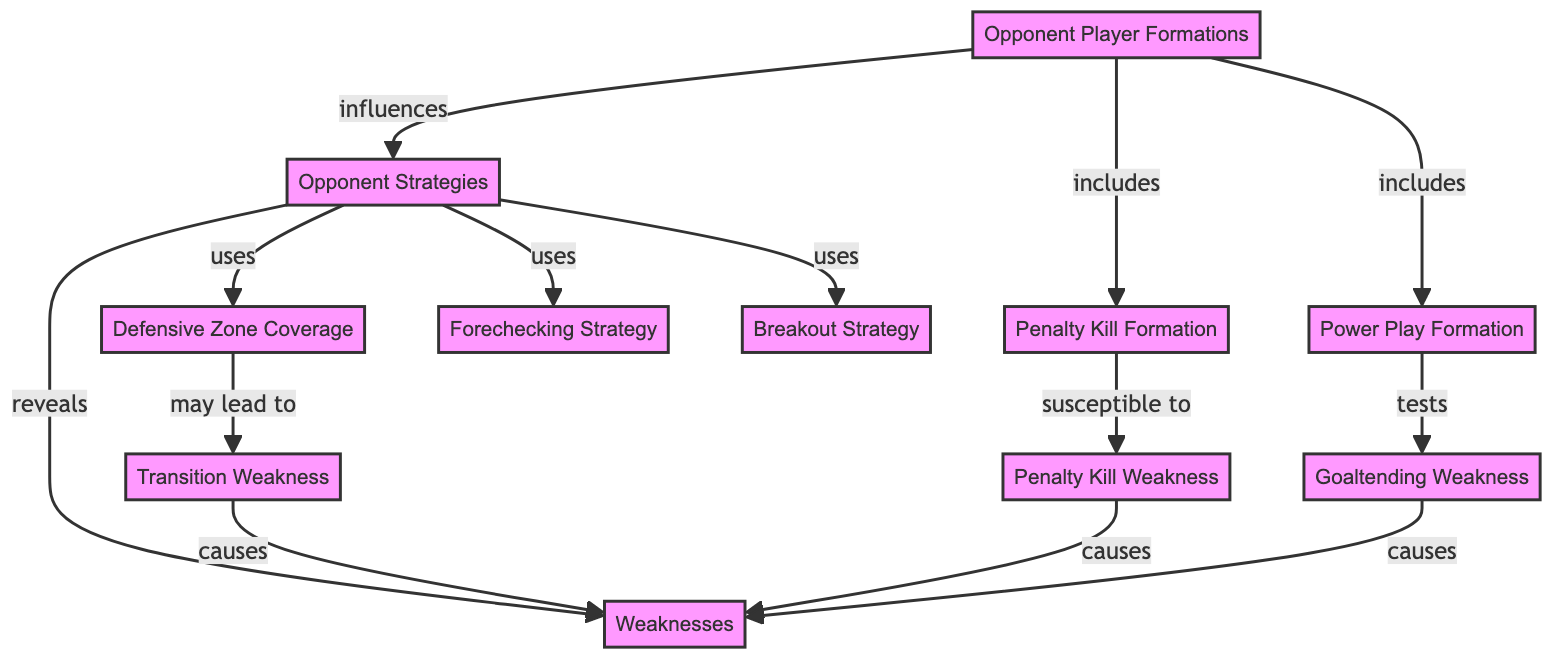What is the total number of nodes in the diagram? There are 11 distinct nodes represented in the diagram that include various aspects of opponent scouting and strategy.
Answer: 11 Which node reveals weaknesses? According to the diagram, the "Opponent Strategies" node connects to the "Weaknesses" node with a "reveals" relationship.
Answer: Opponent Strategies What type of formation is included in the opponent player formations? Looking at the diagram, "Power Play Formation" is listed as one of the formations included in the "Opponent Player Formations" node.
Answer: Power Play Formation What may lead to a transition weakness? The "Defensive Zone Coverage" node is stated to "may lead to" the "Transition Weakness" node in the diagram.
Answer: Defensive Zone Coverage What causes weaknesses related to goaltending? The diagram indicates that the "Goaltending Weakness" is linked to the "Weaknesses" node, showing that it causes weaknesses.
Answer: Goaltending Weakness How many edges connect the opponent strategies to other nodes? Upon reviewing the diagram, the "Opponent Strategies" node connects to three other nodes: "Forechecking Strategy," "Breakout Strategy," and "Defensive Zone Coverage," totaling 3 edges.
Answer: 3 What is susceptible to penalty kill weakness? The diagram explicitly tags "Penalty Kill Formation" as "susceptible to" the "Penalty Kill Weakness," indicating that this formation might show vulnerabilities.
Answer: Penalty Kill Formation Which formation tests the goaltending weakness? According to the visualization, the "Power Play Formation" has a direct relationship labeled "tests" with the "Goaltending Weakness."
Answer: Power Play Formation Which weakness causes the most interconnections with other weaknesses? The "Transition Weakness," "Penalty Kill Weakness," and "Goaltending Weakness" all lead to the "Weaknesses" node, indicating they have significant connections, but they all connect in a similar way, so there might be a tie in terms of connections.
Answer: Transition Weakness and Penalty Kill Weakness and Goaltending Weakness 